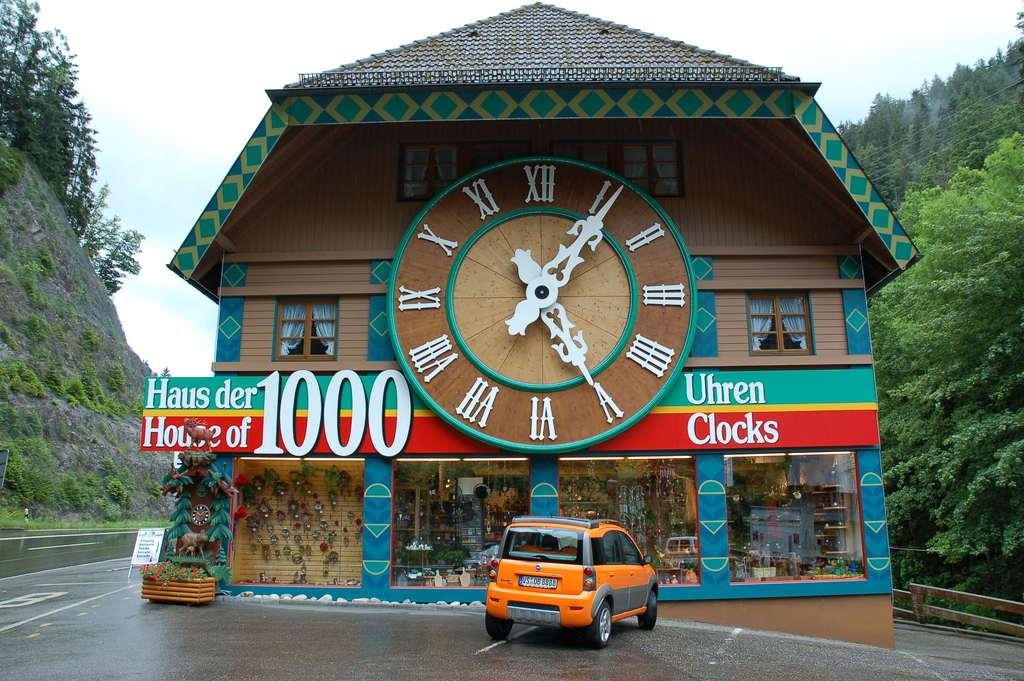<image>
Write a terse but informative summary of the picture. The Hause der 1000 Uhren has a gigantic clock on the outside of the building. 